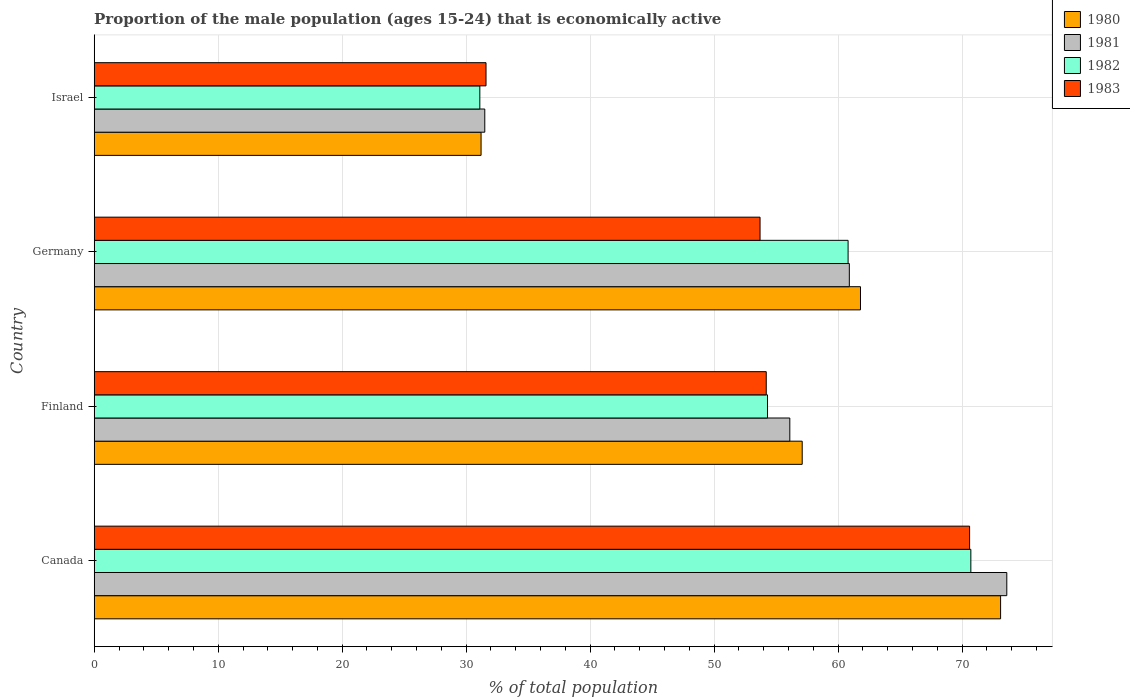How many different coloured bars are there?
Provide a succinct answer. 4. How many groups of bars are there?
Offer a very short reply. 4. Are the number of bars on each tick of the Y-axis equal?
Offer a terse response. Yes. How many bars are there on the 4th tick from the top?
Your answer should be compact. 4. In how many cases, is the number of bars for a given country not equal to the number of legend labels?
Ensure brevity in your answer.  0. What is the proportion of the male population that is economically active in 1981 in Germany?
Your answer should be very brief. 60.9. Across all countries, what is the maximum proportion of the male population that is economically active in 1980?
Ensure brevity in your answer.  73.1. Across all countries, what is the minimum proportion of the male population that is economically active in 1982?
Provide a succinct answer. 31.1. What is the total proportion of the male population that is economically active in 1983 in the graph?
Provide a succinct answer. 210.1. What is the difference between the proportion of the male population that is economically active in 1981 in Finland and that in Israel?
Provide a short and direct response. 24.6. What is the difference between the proportion of the male population that is economically active in 1981 in Israel and the proportion of the male population that is economically active in 1983 in Finland?
Provide a succinct answer. -22.7. What is the average proportion of the male population that is economically active in 1981 per country?
Provide a succinct answer. 55.52. What is the difference between the proportion of the male population that is economically active in 1980 and proportion of the male population that is economically active in 1983 in Finland?
Keep it short and to the point. 2.9. What is the ratio of the proportion of the male population that is economically active in 1983 in Canada to that in Finland?
Offer a very short reply. 1.3. What is the difference between the highest and the second highest proportion of the male population that is economically active in 1981?
Offer a terse response. 12.7. What is the difference between the highest and the lowest proportion of the male population that is economically active in 1983?
Provide a short and direct response. 39. In how many countries, is the proportion of the male population that is economically active in 1982 greater than the average proportion of the male population that is economically active in 1982 taken over all countries?
Offer a terse response. 3. Is the sum of the proportion of the male population that is economically active in 1983 in Finland and Israel greater than the maximum proportion of the male population that is economically active in 1980 across all countries?
Offer a terse response. Yes. Is it the case that in every country, the sum of the proportion of the male population that is economically active in 1983 and proportion of the male population that is economically active in 1982 is greater than the sum of proportion of the male population that is economically active in 1981 and proportion of the male population that is economically active in 1980?
Your answer should be very brief. No. What does the 2nd bar from the top in Germany represents?
Keep it short and to the point. 1982. How many bars are there?
Your response must be concise. 16. What is the difference between two consecutive major ticks on the X-axis?
Your response must be concise. 10. Are the values on the major ticks of X-axis written in scientific E-notation?
Your response must be concise. No. Where does the legend appear in the graph?
Your answer should be very brief. Top right. What is the title of the graph?
Provide a succinct answer. Proportion of the male population (ages 15-24) that is economically active. Does "1992" appear as one of the legend labels in the graph?
Give a very brief answer. No. What is the label or title of the X-axis?
Give a very brief answer. % of total population. What is the label or title of the Y-axis?
Ensure brevity in your answer.  Country. What is the % of total population in 1980 in Canada?
Your answer should be very brief. 73.1. What is the % of total population of 1981 in Canada?
Offer a very short reply. 73.6. What is the % of total population in 1982 in Canada?
Give a very brief answer. 70.7. What is the % of total population of 1983 in Canada?
Offer a terse response. 70.6. What is the % of total population of 1980 in Finland?
Make the answer very short. 57.1. What is the % of total population of 1981 in Finland?
Your answer should be compact. 56.1. What is the % of total population of 1982 in Finland?
Offer a terse response. 54.3. What is the % of total population in 1983 in Finland?
Provide a short and direct response. 54.2. What is the % of total population in 1980 in Germany?
Provide a succinct answer. 61.8. What is the % of total population in 1981 in Germany?
Make the answer very short. 60.9. What is the % of total population of 1982 in Germany?
Provide a short and direct response. 60.8. What is the % of total population of 1983 in Germany?
Offer a very short reply. 53.7. What is the % of total population of 1980 in Israel?
Offer a terse response. 31.2. What is the % of total population in 1981 in Israel?
Your answer should be very brief. 31.5. What is the % of total population of 1982 in Israel?
Ensure brevity in your answer.  31.1. What is the % of total population in 1983 in Israel?
Your answer should be compact. 31.6. Across all countries, what is the maximum % of total population of 1980?
Provide a short and direct response. 73.1. Across all countries, what is the maximum % of total population in 1981?
Make the answer very short. 73.6. Across all countries, what is the maximum % of total population of 1982?
Offer a very short reply. 70.7. Across all countries, what is the maximum % of total population in 1983?
Give a very brief answer. 70.6. Across all countries, what is the minimum % of total population of 1980?
Make the answer very short. 31.2. Across all countries, what is the minimum % of total population in 1981?
Provide a succinct answer. 31.5. Across all countries, what is the minimum % of total population of 1982?
Give a very brief answer. 31.1. Across all countries, what is the minimum % of total population in 1983?
Your response must be concise. 31.6. What is the total % of total population in 1980 in the graph?
Keep it short and to the point. 223.2. What is the total % of total population of 1981 in the graph?
Provide a succinct answer. 222.1. What is the total % of total population of 1982 in the graph?
Provide a short and direct response. 216.9. What is the total % of total population in 1983 in the graph?
Keep it short and to the point. 210.1. What is the difference between the % of total population in 1981 in Canada and that in Finland?
Your response must be concise. 17.5. What is the difference between the % of total population in 1982 in Canada and that in Finland?
Ensure brevity in your answer.  16.4. What is the difference between the % of total population of 1983 in Canada and that in Finland?
Provide a short and direct response. 16.4. What is the difference between the % of total population in 1983 in Canada and that in Germany?
Your answer should be compact. 16.9. What is the difference between the % of total population of 1980 in Canada and that in Israel?
Provide a succinct answer. 41.9. What is the difference between the % of total population in 1981 in Canada and that in Israel?
Your answer should be very brief. 42.1. What is the difference between the % of total population of 1982 in Canada and that in Israel?
Your response must be concise. 39.6. What is the difference between the % of total population of 1983 in Canada and that in Israel?
Provide a short and direct response. 39. What is the difference between the % of total population of 1981 in Finland and that in Germany?
Offer a very short reply. -4.8. What is the difference between the % of total population of 1982 in Finland and that in Germany?
Keep it short and to the point. -6.5. What is the difference between the % of total population of 1980 in Finland and that in Israel?
Your answer should be compact. 25.9. What is the difference between the % of total population of 1981 in Finland and that in Israel?
Ensure brevity in your answer.  24.6. What is the difference between the % of total population of 1982 in Finland and that in Israel?
Make the answer very short. 23.2. What is the difference between the % of total population in 1983 in Finland and that in Israel?
Offer a very short reply. 22.6. What is the difference between the % of total population in 1980 in Germany and that in Israel?
Make the answer very short. 30.6. What is the difference between the % of total population of 1981 in Germany and that in Israel?
Your answer should be very brief. 29.4. What is the difference between the % of total population in 1982 in Germany and that in Israel?
Keep it short and to the point. 29.7. What is the difference between the % of total population of 1983 in Germany and that in Israel?
Offer a terse response. 22.1. What is the difference between the % of total population of 1980 in Canada and the % of total population of 1981 in Finland?
Give a very brief answer. 17. What is the difference between the % of total population of 1980 in Canada and the % of total population of 1983 in Finland?
Keep it short and to the point. 18.9. What is the difference between the % of total population in 1981 in Canada and the % of total population in 1982 in Finland?
Offer a terse response. 19.3. What is the difference between the % of total population in 1982 in Canada and the % of total population in 1983 in Finland?
Offer a terse response. 16.5. What is the difference between the % of total population in 1980 in Canada and the % of total population in 1981 in Germany?
Offer a terse response. 12.2. What is the difference between the % of total population in 1981 in Canada and the % of total population in 1982 in Germany?
Give a very brief answer. 12.8. What is the difference between the % of total population of 1980 in Canada and the % of total population of 1981 in Israel?
Your answer should be very brief. 41.6. What is the difference between the % of total population of 1980 in Canada and the % of total population of 1983 in Israel?
Ensure brevity in your answer.  41.5. What is the difference between the % of total population in 1981 in Canada and the % of total population in 1982 in Israel?
Offer a terse response. 42.5. What is the difference between the % of total population of 1982 in Canada and the % of total population of 1983 in Israel?
Your response must be concise. 39.1. What is the difference between the % of total population of 1980 in Finland and the % of total population of 1982 in Germany?
Make the answer very short. -3.7. What is the difference between the % of total population in 1980 in Finland and the % of total population in 1983 in Germany?
Offer a terse response. 3.4. What is the difference between the % of total population of 1982 in Finland and the % of total population of 1983 in Germany?
Make the answer very short. 0.6. What is the difference between the % of total population in 1980 in Finland and the % of total population in 1981 in Israel?
Provide a succinct answer. 25.6. What is the difference between the % of total population in 1981 in Finland and the % of total population in 1982 in Israel?
Your response must be concise. 25. What is the difference between the % of total population of 1981 in Finland and the % of total population of 1983 in Israel?
Provide a short and direct response. 24.5. What is the difference between the % of total population of 1982 in Finland and the % of total population of 1983 in Israel?
Offer a very short reply. 22.7. What is the difference between the % of total population of 1980 in Germany and the % of total population of 1981 in Israel?
Ensure brevity in your answer.  30.3. What is the difference between the % of total population of 1980 in Germany and the % of total population of 1982 in Israel?
Your answer should be compact. 30.7. What is the difference between the % of total population in 1980 in Germany and the % of total population in 1983 in Israel?
Offer a terse response. 30.2. What is the difference between the % of total population of 1981 in Germany and the % of total population of 1982 in Israel?
Offer a terse response. 29.8. What is the difference between the % of total population in 1981 in Germany and the % of total population in 1983 in Israel?
Give a very brief answer. 29.3. What is the difference between the % of total population of 1982 in Germany and the % of total population of 1983 in Israel?
Offer a terse response. 29.2. What is the average % of total population in 1980 per country?
Provide a succinct answer. 55.8. What is the average % of total population of 1981 per country?
Your answer should be very brief. 55.52. What is the average % of total population of 1982 per country?
Your response must be concise. 54.23. What is the average % of total population in 1983 per country?
Your answer should be compact. 52.52. What is the difference between the % of total population in 1980 and % of total population in 1981 in Canada?
Ensure brevity in your answer.  -0.5. What is the difference between the % of total population in 1980 and % of total population in 1982 in Canada?
Make the answer very short. 2.4. What is the difference between the % of total population of 1980 and % of total population of 1983 in Canada?
Provide a succinct answer. 2.5. What is the difference between the % of total population of 1982 and % of total population of 1983 in Canada?
Keep it short and to the point. 0.1. What is the difference between the % of total population of 1980 and % of total population of 1982 in Finland?
Provide a short and direct response. 2.8. What is the difference between the % of total population of 1982 and % of total population of 1983 in Finland?
Provide a succinct answer. 0.1. What is the difference between the % of total population in 1980 and % of total population in 1982 in Germany?
Make the answer very short. 1. What is the difference between the % of total population in 1980 and % of total population in 1981 in Israel?
Keep it short and to the point. -0.3. What is the difference between the % of total population of 1980 and % of total population of 1982 in Israel?
Your answer should be compact. 0.1. What is the difference between the % of total population of 1981 and % of total population of 1982 in Israel?
Keep it short and to the point. 0.4. What is the ratio of the % of total population in 1980 in Canada to that in Finland?
Offer a very short reply. 1.28. What is the ratio of the % of total population of 1981 in Canada to that in Finland?
Your answer should be very brief. 1.31. What is the ratio of the % of total population in 1982 in Canada to that in Finland?
Offer a terse response. 1.3. What is the ratio of the % of total population of 1983 in Canada to that in Finland?
Offer a very short reply. 1.3. What is the ratio of the % of total population in 1980 in Canada to that in Germany?
Your answer should be compact. 1.18. What is the ratio of the % of total population of 1981 in Canada to that in Germany?
Offer a terse response. 1.21. What is the ratio of the % of total population of 1982 in Canada to that in Germany?
Ensure brevity in your answer.  1.16. What is the ratio of the % of total population in 1983 in Canada to that in Germany?
Your answer should be compact. 1.31. What is the ratio of the % of total population in 1980 in Canada to that in Israel?
Your answer should be very brief. 2.34. What is the ratio of the % of total population in 1981 in Canada to that in Israel?
Make the answer very short. 2.34. What is the ratio of the % of total population of 1982 in Canada to that in Israel?
Provide a short and direct response. 2.27. What is the ratio of the % of total population of 1983 in Canada to that in Israel?
Your response must be concise. 2.23. What is the ratio of the % of total population in 1980 in Finland to that in Germany?
Make the answer very short. 0.92. What is the ratio of the % of total population in 1981 in Finland to that in Germany?
Make the answer very short. 0.92. What is the ratio of the % of total population in 1982 in Finland to that in Germany?
Make the answer very short. 0.89. What is the ratio of the % of total population in 1983 in Finland to that in Germany?
Provide a short and direct response. 1.01. What is the ratio of the % of total population of 1980 in Finland to that in Israel?
Provide a short and direct response. 1.83. What is the ratio of the % of total population of 1981 in Finland to that in Israel?
Offer a very short reply. 1.78. What is the ratio of the % of total population of 1982 in Finland to that in Israel?
Provide a succinct answer. 1.75. What is the ratio of the % of total population in 1983 in Finland to that in Israel?
Offer a terse response. 1.72. What is the ratio of the % of total population of 1980 in Germany to that in Israel?
Provide a short and direct response. 1.98. What is the ratio of the % of total population in 1981 in Germany to that in Israel?
Your answer should be very brief. 1.93. What is the ratio of the % of total population of 1982 in Germany to that in Israel?
Give a very brief answer. 1.96. What is the ratio of the % of total population of 1983 in Germany to that in Israel?
Provide a short and direct response. 1.7. What is the difference between the highest and the second highest % of total population in 1980?
Offer a terse response. 11.3. What is the difference between the highest and the lowest % of total population of 1980?
Keep it short and to the point. 41.9. What is the difference between the highest and the lowest % of total population of 1981?
Your answer should be compact. 42.1. What is the difference between the highest and the lowest % of total population in 1982?
Give a very brief answer. 39.6. What is the difference between the highest and the lowest % of total population of 1983?
Provide a short and direct response. 39. 